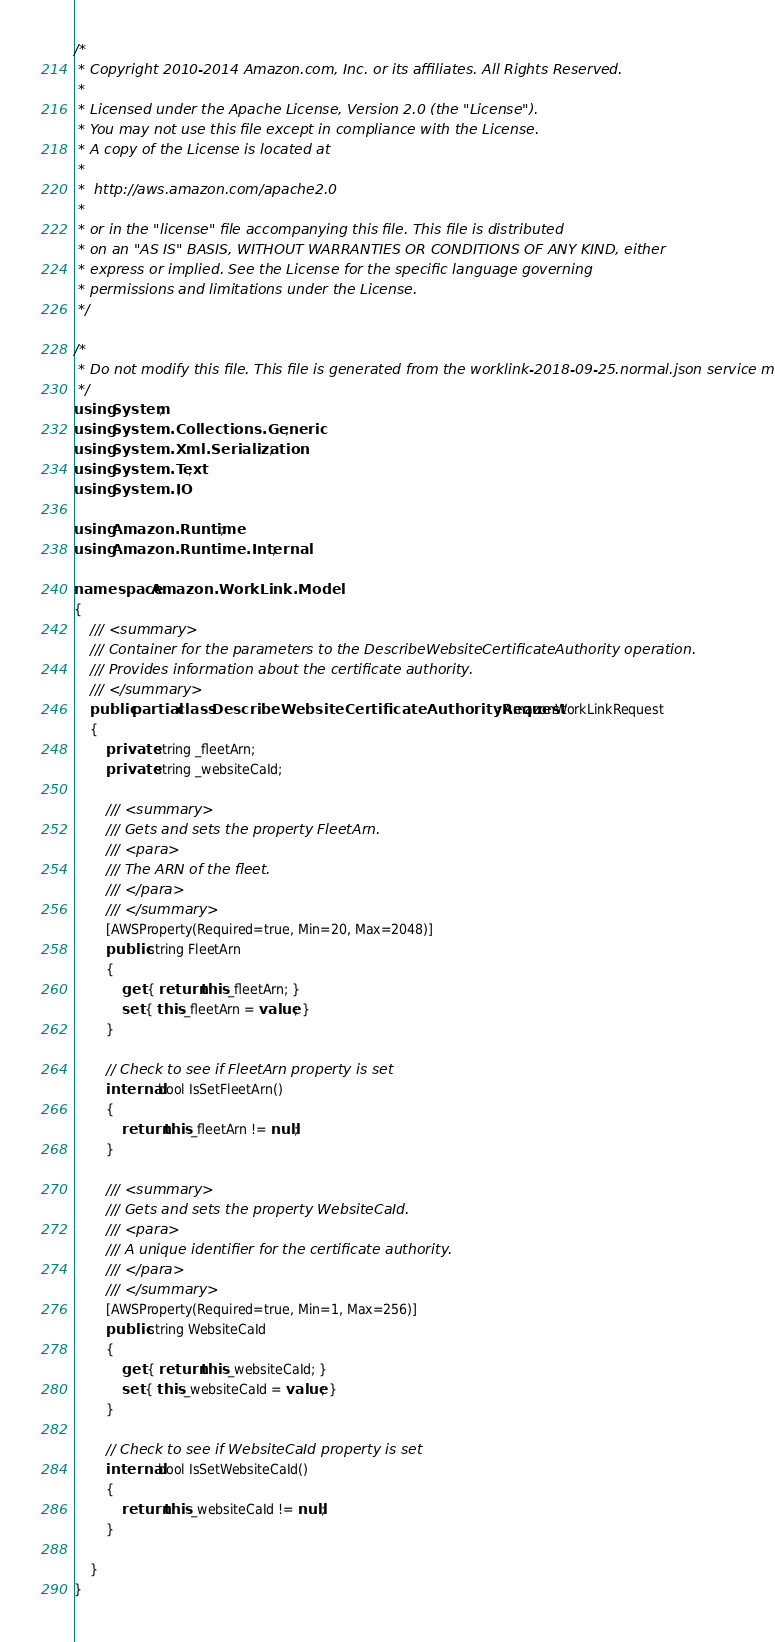<code> <loc_0><loc_0><loc_500><loc_500><_C#_>/*
 * Copyright 2010-2014 Amazon.com, Inc. or its affiliates. All Rights Reserved.
 * 
 * Licensed under the Apache License, Version 2.0 (the "License").
 * You may not use this file except in compliance with the License.
 * A copy of the License is located at
 * 
 *  http://aws.amazon.com/apache2.0
 * 
 * or in the "license" file accompanying this file. This file is distributed
 * on an "AS IS" BASIS, WITHOUT WARRANTIES OR CONDITIONS OF ANY KIND, either
 * express or implied. See the License for the specific language governing
 * permissions and limitations under the License.
 */

/*
 * Do not modify this file. This file is generated from the worklink-2018-09-25.normal.json service model.
 */
using System;
using System.Collections.Generic;
using System.Xml.Serialization;
using System.Text;
using System.IO;

using Amazon.Runtime;
using Amazon.Runtime.Internal;

namespace Amazon.WorkLink.Model
{
    /// <summary>
    /// Container for the parameters to the DescribeWebsiteCertificateAuthority operation.
    /// Provides information about the certificate authority.
    /// </summary>
    public partial class DescribeWebsiteCertificateAuthorityRequest : AmazonWorkLinkRequest
    {
        private string _fleetArn;
        private string _websiteCaId;

        /// <summary>
        /// Gets and sets the property FleetArn. 
        /// <para>
        /// The ARN of the fleet.
        /// </para>
        /// </summary>
        [AWSProperty(Required=true, Min=20, Max=2048)]
        public string FleetArn
        {
            get { return this._fleetArn; }
            set { this._fleetArn = value; }
        }

        // Check to see if FleetArn property is set
        internal bool IsSetFleetArn()
        {
            return this._fleetArn != null;
        }

        /// <summary>
        /// Gets and sets the property WebsiteCaId. 
        /// <para>
        /// A unique identifier for the certificate authority.
        /// </para>
        /// </summary>
        [AWSProperty(Required=true, Min=1, Max=256)]
        public string WebsiteCaId
        {
            get { return this._websiteCaId; }
            set { this._websiteCaId = value; }
        }

        // Check to see if WebsiteCaId property is set
        internal bool IsSetWebsiteCaId()
        {
            return this._websiteCaId != null;
        }

    }
}</code> 